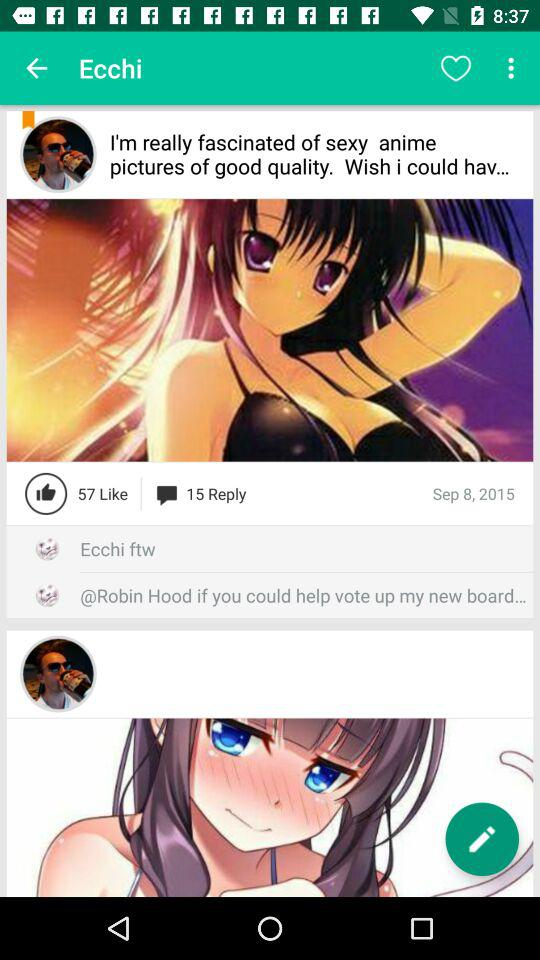What is the name of the application?
When the provided information is insufficient, respond with <no answer>. <no answer> 